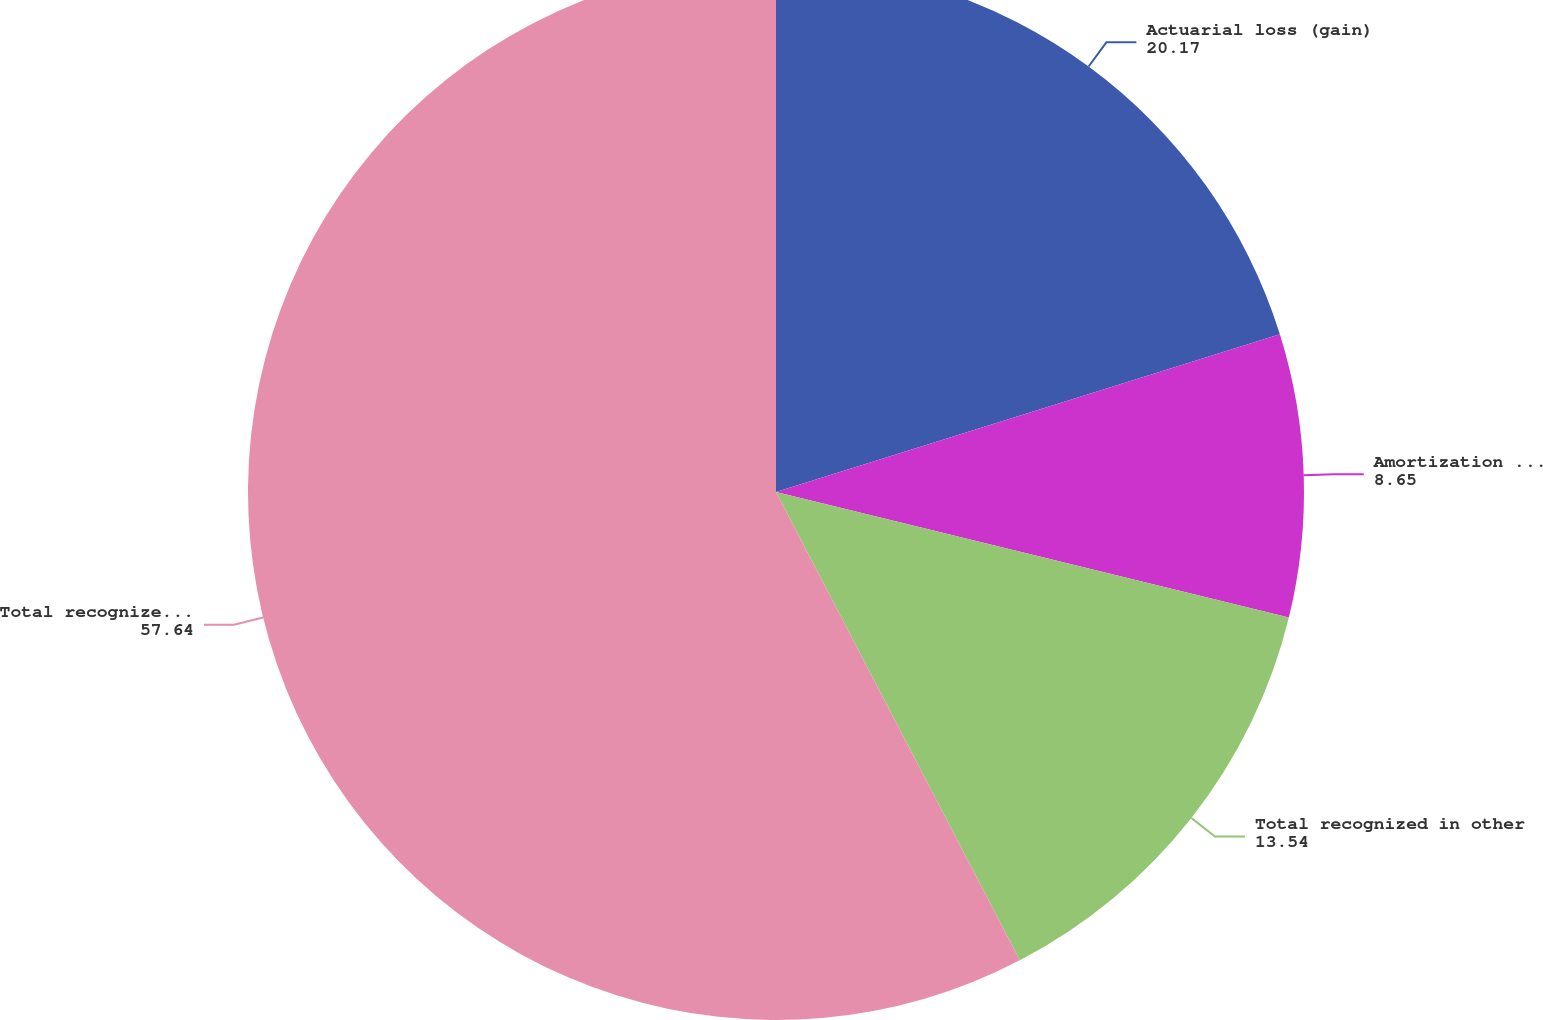<chart> <loc_0><loc_0><loc_500><loc_500><pie_chart><fcel>Actuarial loss (gain)<fcel>Amortization of actuarial loss<fcel>Total recognized in other<fcel>Total recognized in net<nl><fcel>20.17%<fcel>8.65%<fcel>13.54%<fcel>57.64%<nl></chart> 